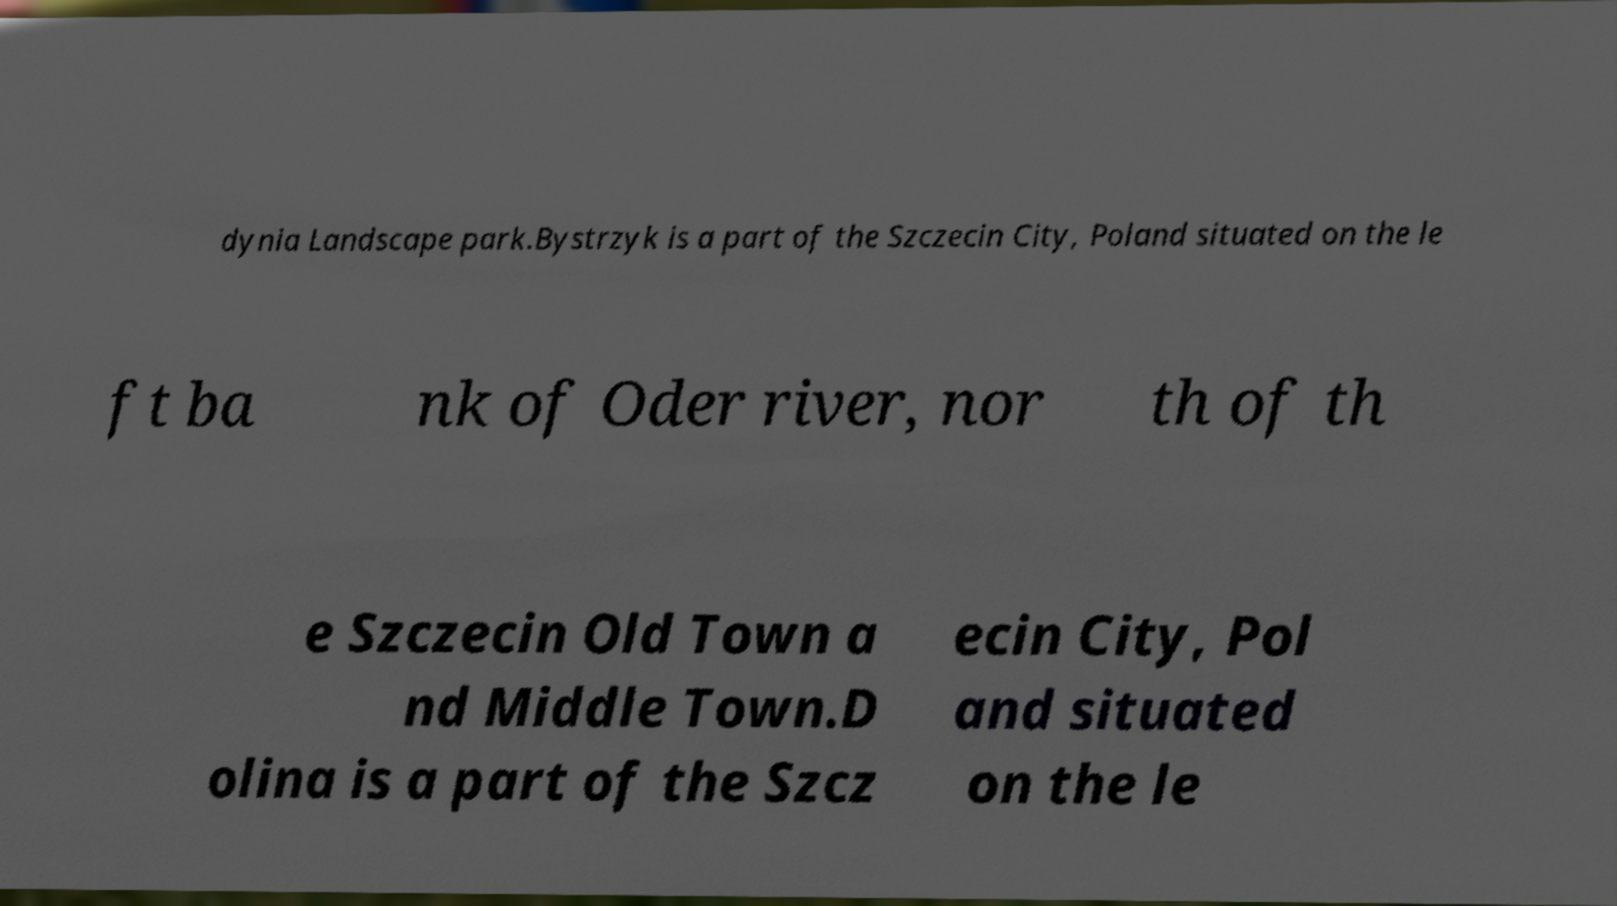Could you extract and type out the text from this image? dynia Landscape park.Bystrzyk is a part of the Szczecin City, Poland situated on the le ft ba nk of Oder river, nor th of th e Szczecin Old Town a nd Middle Town.D olina is a part of the Szcz ecin City, Pol and situated on the le 